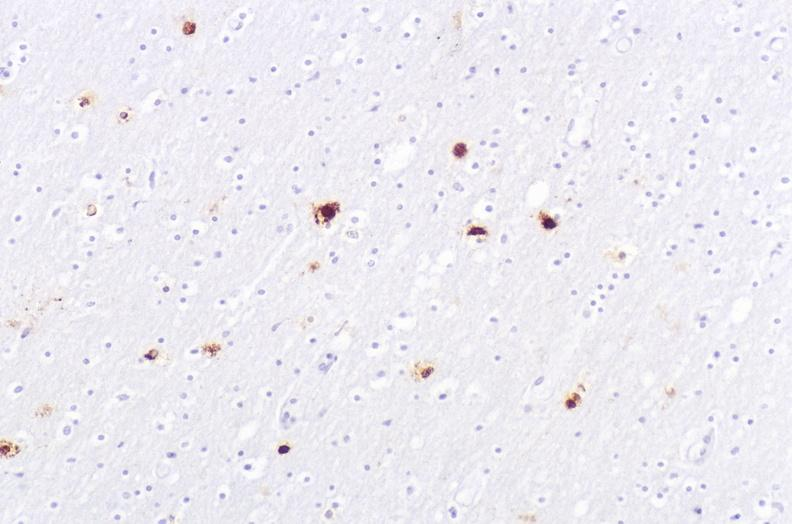does this image show herpes simplex virus, brain, immunohistochemistry?
Answer the question using a single word or phrase. Yes 